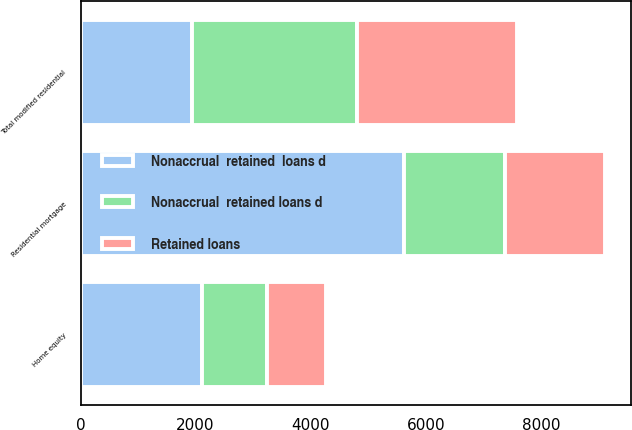<chart> <loc_0><loc_0><loc_500><loc_500><stacked_bar_chart><ecel><fcel>Residential mortgage<fcel>Home equity<fcel>Total modified residential<nl><fcel>Nonaccrual  retained  loans d<fcel>5620<fcel>2118<fcel>1936.5<nl><fcel>Retained loans<fcel>1743<fcel>1032<fcel>2775<nl><fcel>Nonaccrual  retained loans d<fcel>1755<fcel>1116<fcel>2871<nl></chart> 